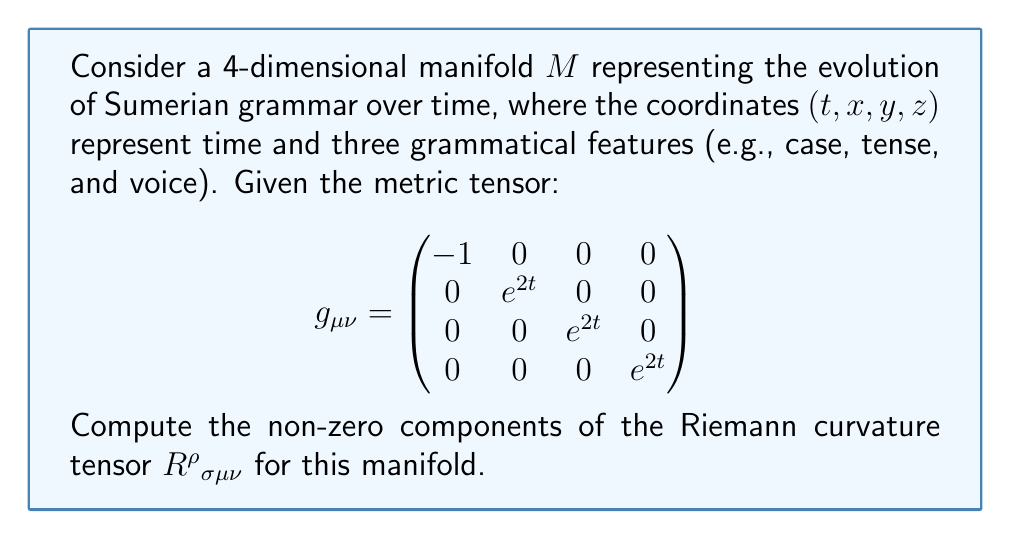Solve this math problem. To compute the Riemann curvature tensor, we'll follow these steps:

1) First, we need to calculate the Christoffel symbols $\Gamma^\rho_{\mu\nu}$:
   $$\Gamma^\rho_{\mu\nu} = \frac{1}{2}g^{\rho\lambda}(\partial_\mu g_{\nu\lambda} + \partial_\nu g_{\mu\lambda} - \partial_\lambda g_{\mu\nu})$$

2) The non-zero Christoffel symbols are:
   $$\Gamma^i_{ti} = \Gamma^i_{it} = 1$$ for $i = 1, 2, 3$

3) Now, we can calculate the Riemann tensor using the formula:
   $$R^\rho{}_{\sigma\mu\nu} = \partial_\mu \Gamma^\rho_{\nu\sigma} - \partial_\nu \Gamma^\rho_{\mu\sigma} + \Gamma^\rho_{\mu\lambda}\Gamma^\lambda_{\nu\sigma} - \Gamma^\rho_{\nu\lambda}\Gamma^\lambda_{\mu\sigma}$$

4) The non-zero components are:
   $$R^i{}_{tit} = \partial_t \Gamma^i_{it} - \partial_i \Gamma^i_{tt} + \Gamma^i_{t\lambda}\Gamma^\lambda_{it} - \Gamma^i_{i\lambda}\Gamma^\lambda_{tt}$$
   $$R^i{}_{tit} = \partial_t (1) - 0 + \Gamma^i_{ti}\Gamma^i_{it} - 0 = 0 + 1 = 1$$

5) Due to the symmetries of the Riemann tensor, we also have:
   $$R^i{}_{tti} = -R^i{}_{tit} = -1$$

6) All other components are zero.

Note: In this context, $i$ represents the spatial indices 1, 2, and 3, corresponding to the grammatical features x, y, and z.
Answer: $R^i{}_{tit} = 1$, $R^i{}_{tti} = -1$ for $i = 1, 2, 3$; all other components are zero. 